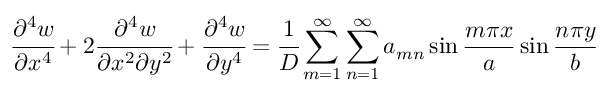<formula> <loc_0><loc_0><loc_500><loc_500>{ \cfrac { \partial ^ { 4 } w } { \partial x ^ { 4 } } } + 2 { \cfrac { \partial ^ { 4 } w } { \partial x ^ { 2 } \partial y ^ { 2 } } } + { \cfrac { \partial ^ { 4 } w } { \partial y ^ { 4 } } } = { \cfrac { 1 } { D } } \sum _ { m = 1 } ^ { \infty } \sum _ { n = 1 } ^ { \infty } a _ { m n } \sin { \frac { m \pi x } { a } } \sin { \frac { n \pi y } { b } }</formula> 